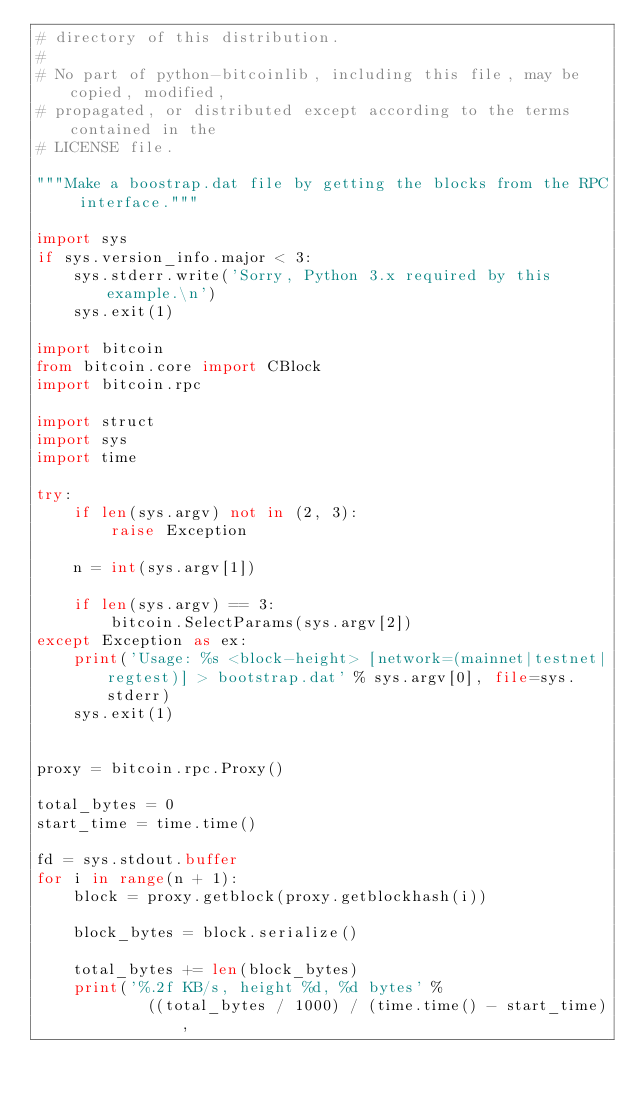<code> <loc_0><loc_0><loc_500><loc_500><_Python_># directory of this distribution.
#
# No part of python-bitcoinlib, including this file, may be copied, modified,
# propagated, or distributed except according to the terms contained in the
# LICENSE file.

"""Make a boostrap.dat file by getting the blocks from the RPC interface."""

import sys
if sys.version_info.major < 3:
    sys.stderr.write('Sorry, Python 3.x required by this example.\n')
    sys.exit(1)

import bitcoin
from bitcoin.core import CBlock
import bitcoin.rpc

import struct
import sys
import time

try:
    if len(sys.argv) not in (2, 3):
        raise Exception

    n = int(sys.argv[1])

    if len(sys.argv) == 3:
        bitcoin.SelectParams(sys.argv[2])
except Exception as ex:
    print('Usage: %s <block-height> [network=(mainnet|testnet|regtest)] > bootstrap.dat' % sys.argv[0], file=sys.stderr)
    sys.exit(1)


proxy = bitcoin.rpc.Proxy()

total_bytes = 0
start_time = time.time()

fd = sys.stdout.buffer
for i in range(n + 1):
    block = proxy.getblock(proxy.getblockhash(i))

    block_bytes = block.serialize()

    total_bytes += len(block_bytes)
    print('%.2f KB/s, height %d, %d bytes' %
            ((total_bytes / 1000) / (time.time() - start_time),</code> 